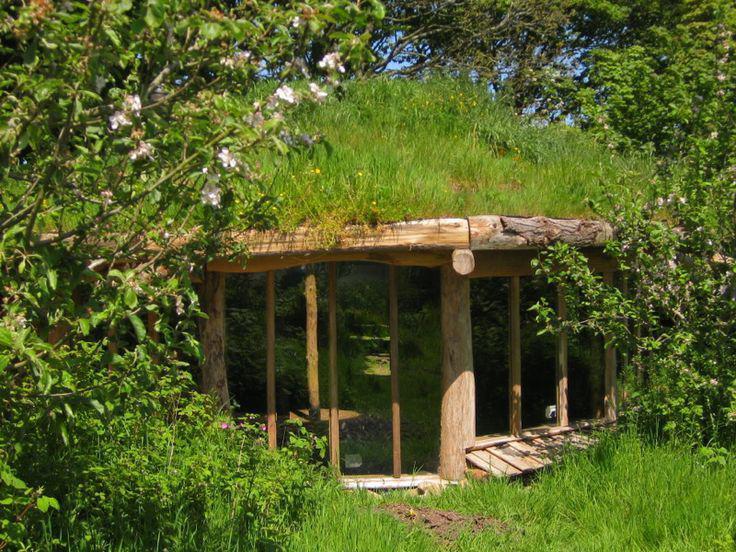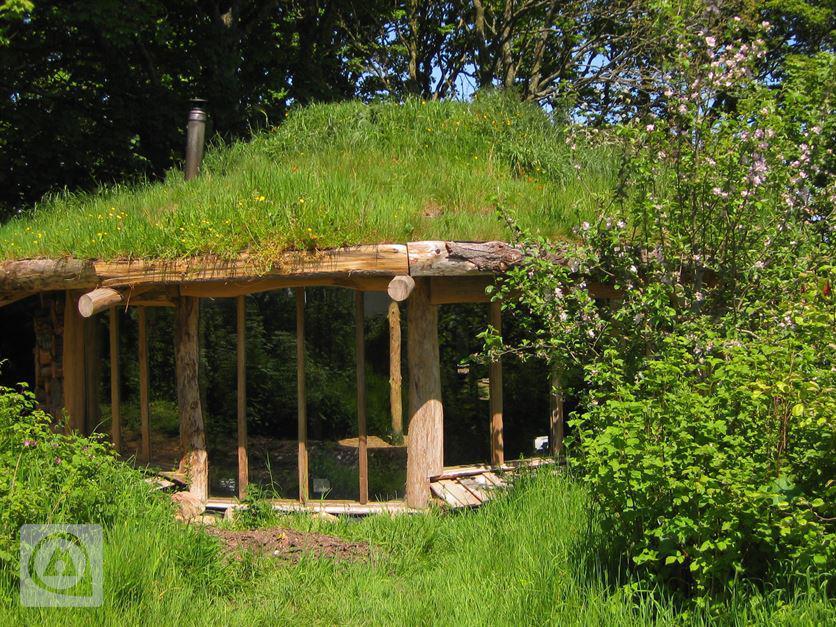The first image is the image on the left, the second image is the image on the right. Considering the images on both sides, is "There is an ax in the image on the right." valid? Answer yes or no. No. 